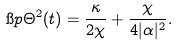Convert formula to latex. <formula><loc_0><loc_0><loc_500><loc_500>\i p { \Theta ^ { 2 } ( t ) } = \frac { \kappa } { 2 \chi } + \frac { \chi } { 4 | \alpha | ^ { 2 } } .</formula> 